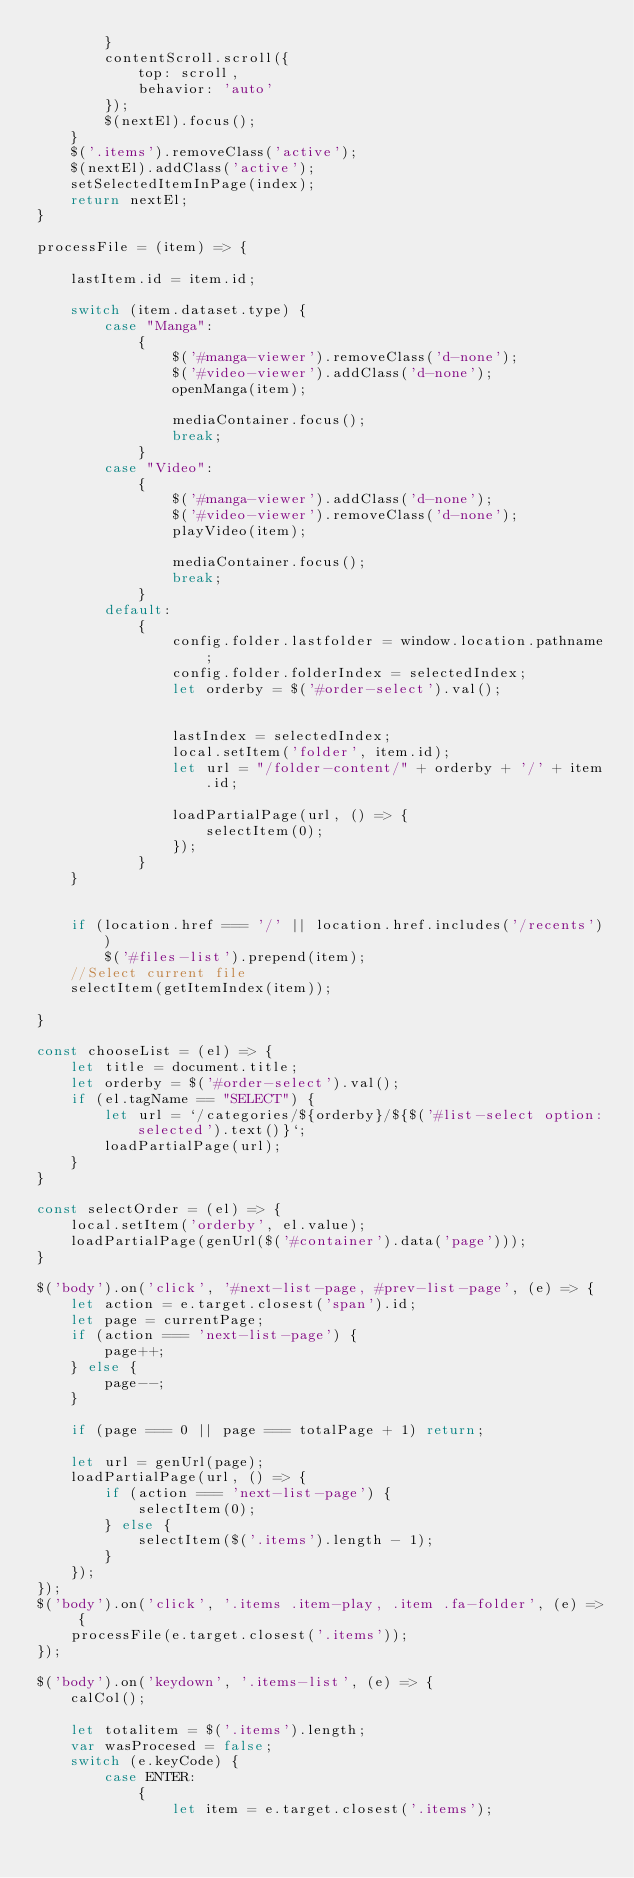Convert code to text. <code><loc_0><loc_0><loc_500><loc_500><_JavaScript_>        }
        contentScroll.scroll({
            top: scroll,
            behavior: 'auto'
        });
        $(nextEl).focus();
    }
    $('.items').removeClass('active');
    $(nextEl).addClass('active');
    setSelectedItemInPage(index);
    return nextEl;
}

processFile = (item) => {

    lastItem.id = item.id;

    switch (item.dataset.type) {
        case "Manga":
            {
                $('#manga-viewer').removeClass('d-none');
                $('#video-viewer').addClass('d-none');
                openManga(item);

                mediaContainer.focus();
                break;
            }
        case "Video":
            {
                $('#manga-viewer').addClass('d-none');
                $('#video-viewer').removeClass('d-none');
                playVideo(item);

                mediaContainer.focus();
                break;
            }
        default:
            {
                config.folder.lastfolder = window.location.pathname;
                config.folder.folderIndex = selectedIndex;
                let orderby = $('#order-select').val();


                lastIndex = selectedIndex;
                local.setItem('folder', item.id);
                let url = "/folder-content/" + orderby + '/' + item.id;

                loadPartialPage(url, () => {
                    selectItem(0);
                });
            }
    }


    if (location.href === '/' || location.href.includes('/recents'))
        $('#files-list').prepend(item);
    //Select current file
    selectItem(getItemIndex(item));

}

const chooseList = (el) => {
    let title = document.title;
    let orderby = $('#order-select').val();
    if (el.tagName == "SELECT") {
        let url = `/categories/${orderby}/${$('#list-select option:selected').text()}`;
        loadPartialPage(url);
    }
}

const selectOrder = (el) => {
    local.setItem('orderby', el.value);
    loadPartialPage(genUrl($('#container').data('page')));
}

$('body').on('click', '#next-list-page, #prev-list-page', (e) => {
    let action = e.target.closest('span').id;
    let page = currentPage;
    if (action === 'next-list-page') {
        page++;
    } else {
        page--;
    }

    if (page === 0 || page === totalPage + 1) return;

    let url = genUrl(page);
    loadPartialPage(url, () => {
        if (action === 'next-list-page') {
            selectItem(0);
        } else {
            selectItem($('.items').length - 1);
        }
    });
});
$('body').on('click', '.items .item-play, .item .fa-folder', (e) => {
    processFile(e.target.closest('.items'));
});

$('body').on('keydown', '.items-list', (e) => {
    calCol();

    let totalitem = $('.items').length;
    var wasProcesed = false;
    switch (e.keyCode) {
        case ENTER:
            {
                let item = e.target.closest('.items');</code> 